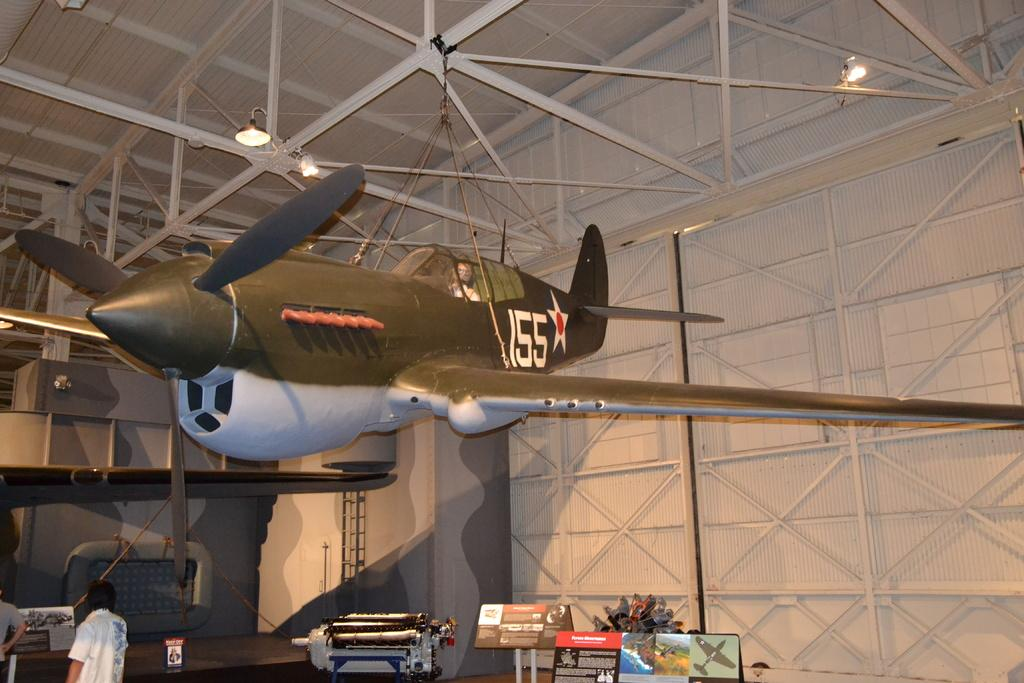Provide a one-sentence caption for the provided image. A small airplane in a hangar with 155 on its tail. 